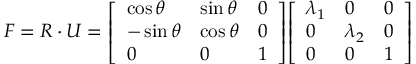Convert formula to latex. <formula><loc_0><loc_0><loc_500><loc_500>{ F } = { R } \cdot { U } = { \left [ \begin{array} { l l l } { \cos \theta } & { \sin \theta } & { 0 } \\ { - \sin \theta } & { \cos \theta } & { 0 } \\ { 0 } & { 0 } & { 1 } \end{array} \right ] } { \left [ \begin{array} { l l l } { \lambda _ { 1 } } & { 0 } & { 0 } \\ { 0 } & { \lambda _ { 2 } } & { 0 } \\ { 0 } & { 0 } & { 1 } \end{array} \right ] }</formula> 